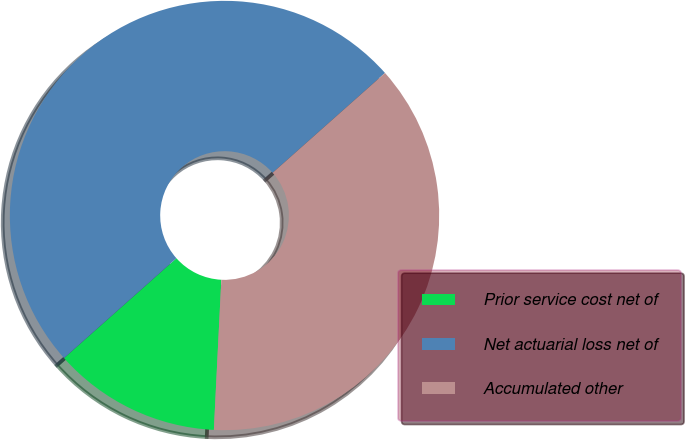Convert chart to OTSL. <chart><loc_0><loc_0><loc_500><loc_500><pie_chart><fcel>Prior service cost net of<fcel>Net actuarial loss net of<fcel>Accumulated other<nl><fcel>12.65%<fcel>50.0%<fcel>37.35%<nl></chart> 